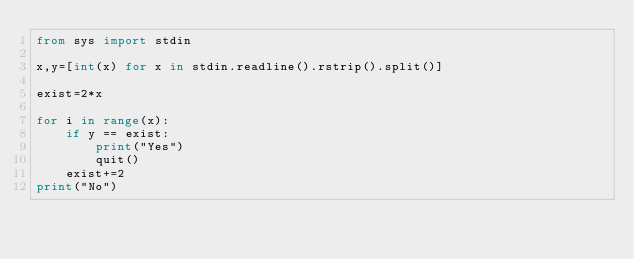Convert code to text. <code><loc_0><loc_0><loc_500><loc_500><_Python_>from sys import stdin

x,y=[int(x) for x in stdin.readline().rstrip().split()]

exist=2*x

for i in range(x):
    if y == exist:
        print("Yes")
        quit()
    exist+=2
print("No")
</code> 